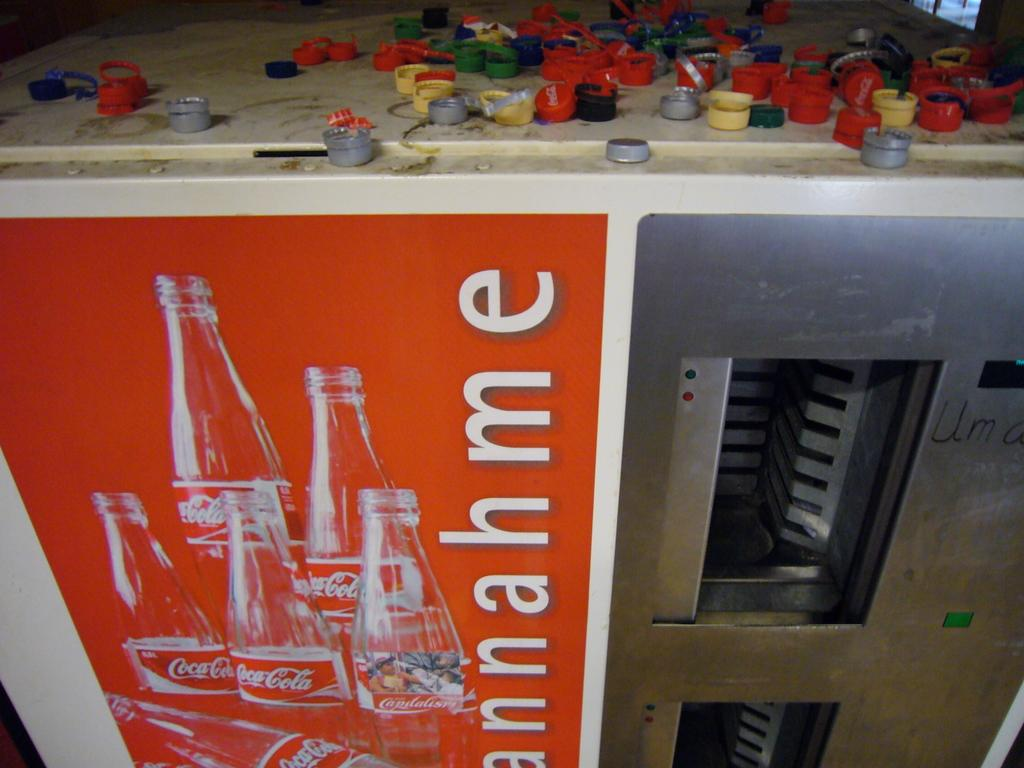<image>
Describe the image concisely. A coca cola vending machine has a large number of coloured bottle tops scattered on its top. 